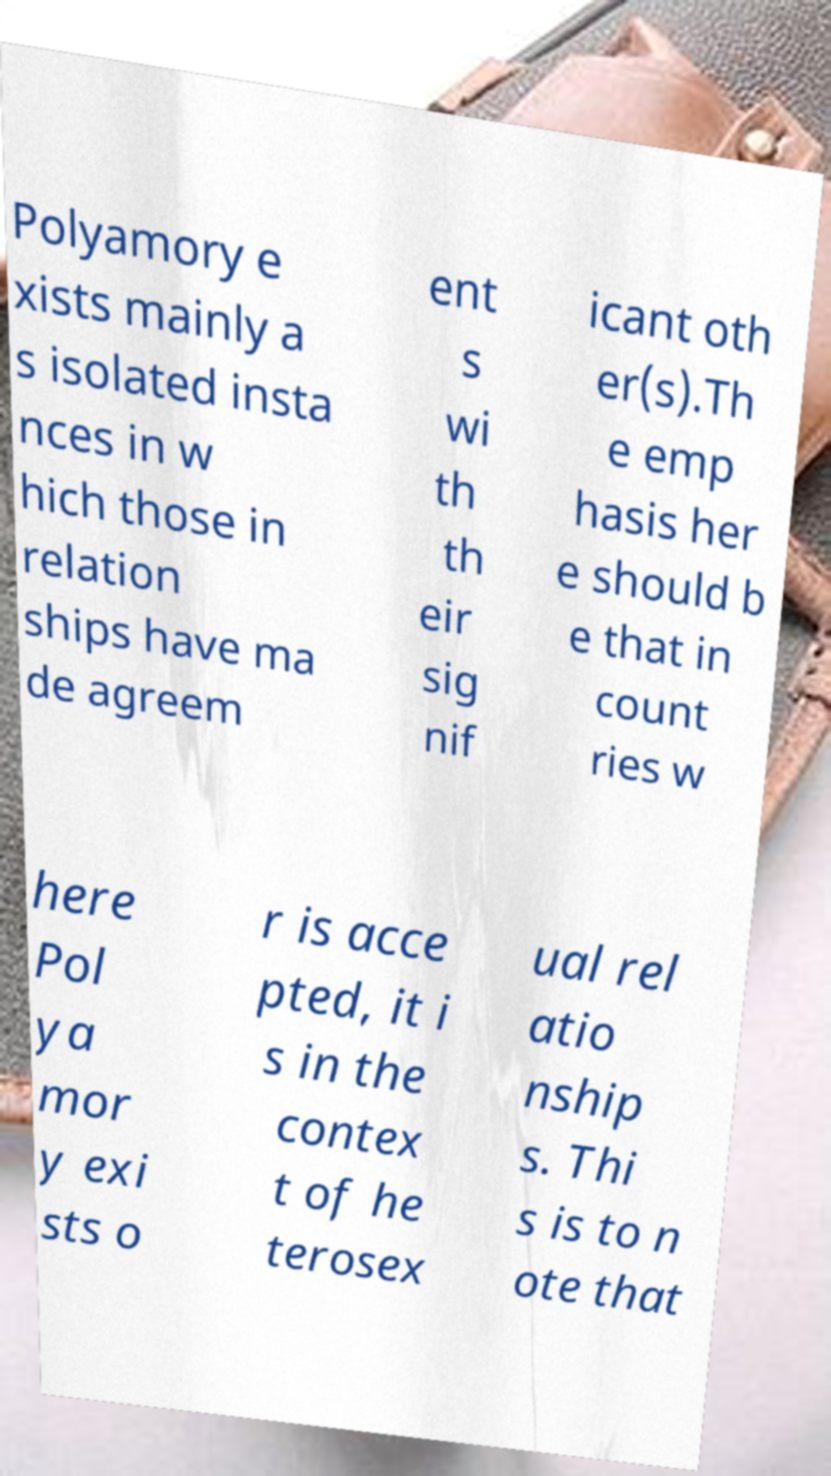I need the written content from this picture converted into text. Can you do that? Polyamory e xists mainly a s isolated insta nces in w hich those in relation ships have ma de agreem ent s wi th th eir sig nif icant oth er(s).Th e emp hasis her e should b e that in count ries w here Pol ya mor y exi sts o r is acce pted, it i s in the contex t of he terosex ual rel atio nship s. Thi s is to n ote that 